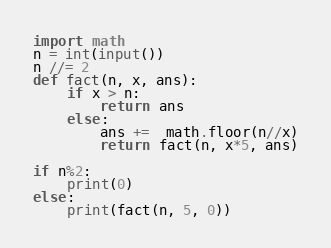Convert code to text. <code><loc_0><loc_0><loc_500><loc_500><_Python_>import math
n = int(input())
n //= 2
def fact(n, x, ans):
    if x > n:
        return ans
    else:
        ans +=  math.floor(n//x)
        return fact(n, x*5, ans)

if n%2:
    print(0)
else:
    print(fact(n, 5, 0))</code> 